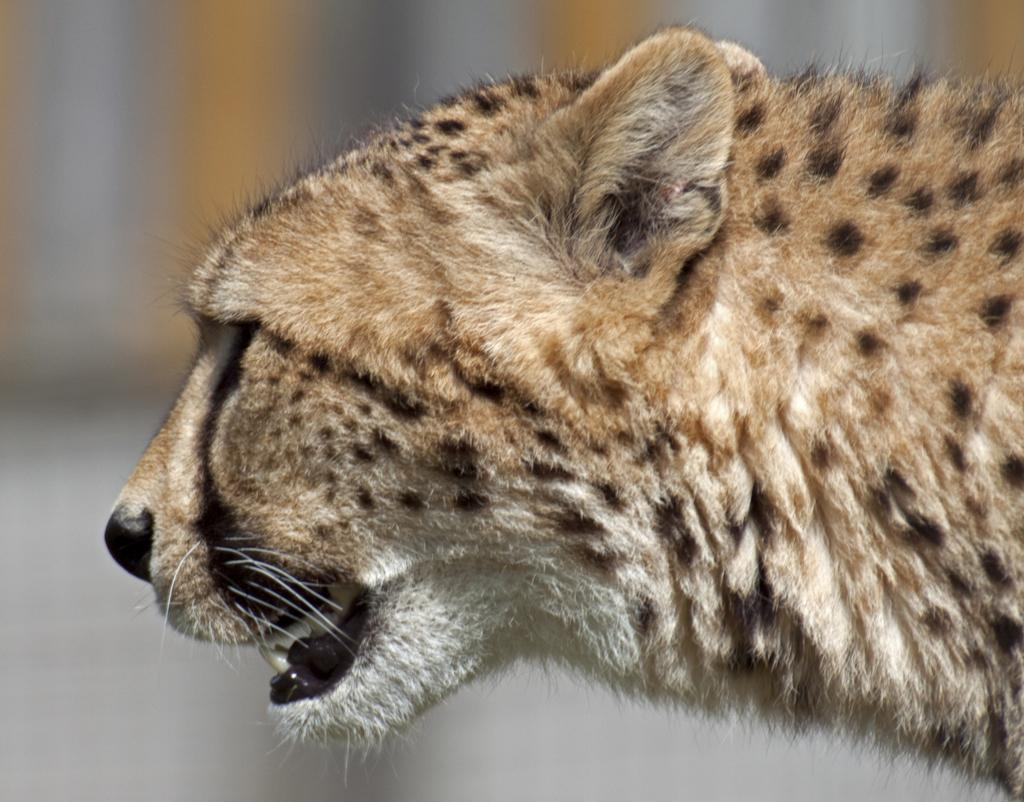What animal is the main subject of the picture? There is a cheetah in the picture. Can you describe the cheetah's facial expression in the image? The cheetah's face is visible in a side view. What can you tell about the background of the image? The background of the image is not clear. How many women are sitting on the cart in the image? There are no women or carts present in the image; it features a cheetah with a side view of its face. What color is the lipstick worn by the woman in the image? There is no woman or lipstick present in the image. 